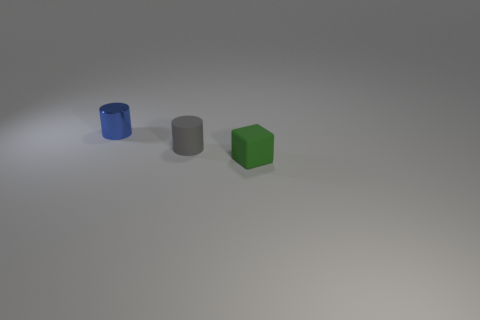There is another object that is the same shape as the small blue metal thing; what is its material?
Your answer should be very brief. Rubber. Is there anything else that is the same size as the blue object?
Provide a short and direct response. Yes. Are any gray rubber things visible?
Make the answer very short. Yes. What is the thing that is behind the cylinder that is on the right side of the cylinder left of the tiny gray object made of?
Offer a terse response. Metal. Does the green object have the same shape as the small rubber object that is left of the small green rubber cube?
Provide a short and direct response. No. What number of other small objects have the same shape as the blue metallic thing?
Make the answer very short. 1. What is the shape of the metal object?
Offer a terse response. Cylinder. There is a matte object to the left of the small matte object in front of the gray cylinder; what size is it?
Provide a short and direct response. Small. How many objects are metallic cylinders or small blocks?
Make the answer very short. 2. Is the shape of the gray thing the same as the green rubber thing?
Offer a terse response. No. 